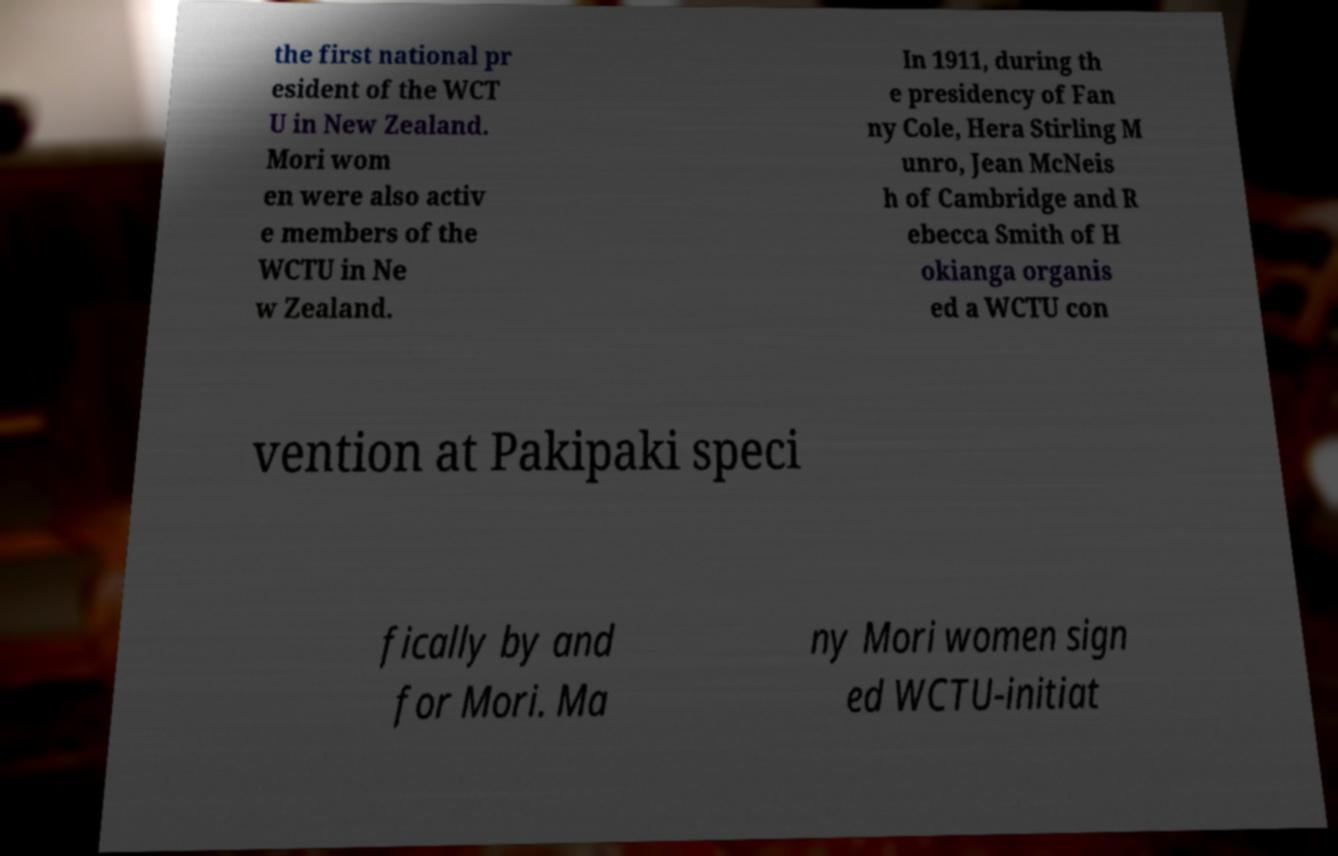Could you assist in decoding the text presented in this image and type it out clearly? the first national pr esident of the WCT U in New Zealand. Mori wom en were also activ e members of the WCTU in Ne w Zealand. In 1911, during th e presidency of Fan ny Cole, Hera Stirling M unro, Jean McNeis h of Cambridge and R ebecca Smith of H okianga organis ed a WCTU con vention at Pakipaki speci fically by and for Mori. Ma ny Mori women sign ed WCTU-initiat 